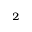<formula> <loc_0><loc_0><loc_500><loc_500>_ { 2 }</formula> 